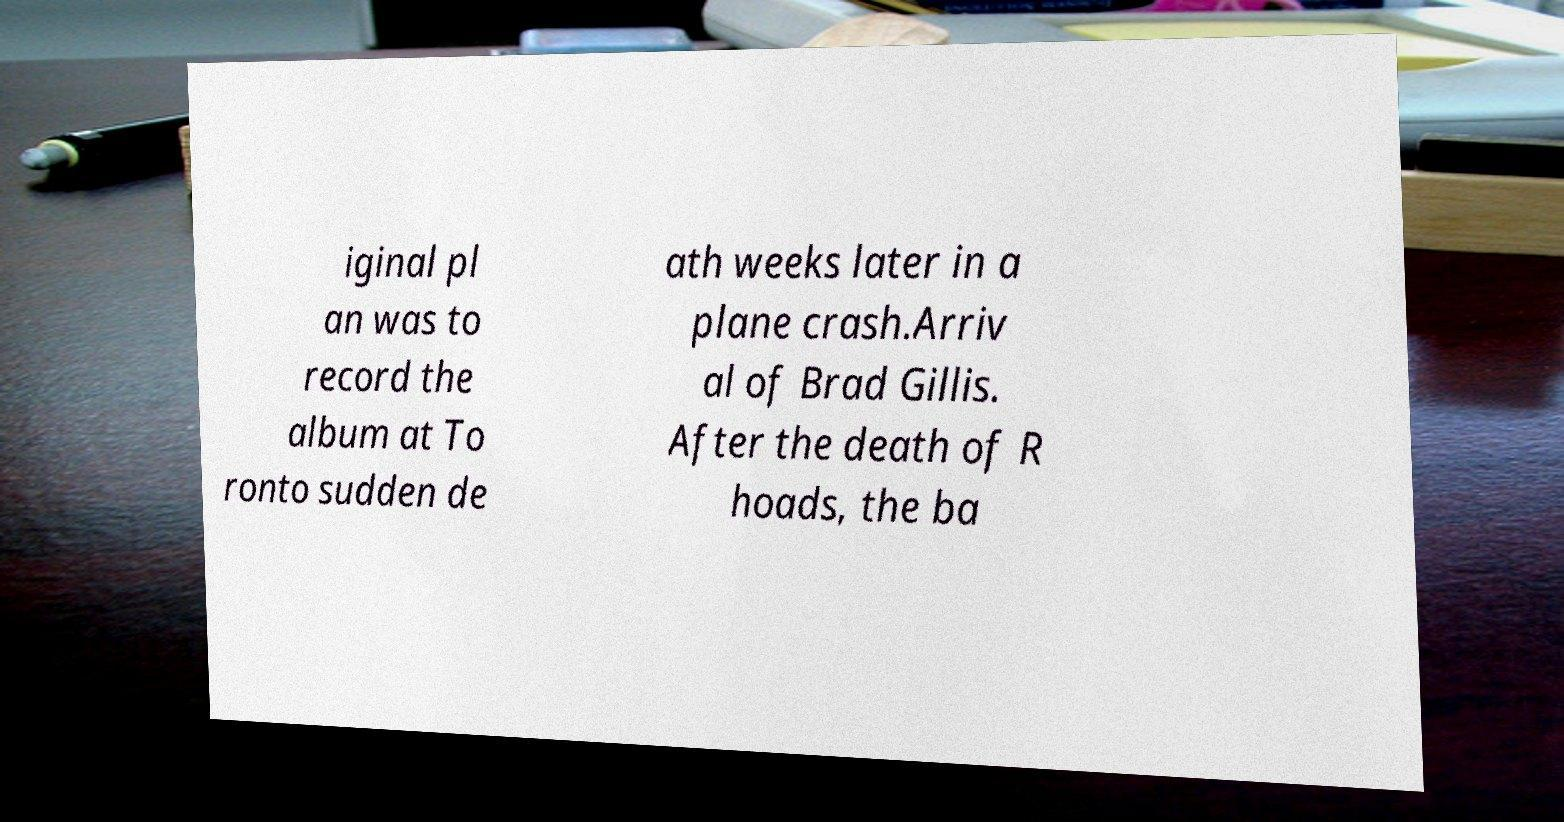Please read and relay the text visible in this image. What does it say? iginal pl an was to record the album at To ronto sudden de ath weeks later in a plane crash.Arriv al of Brad Gillis. After the death of R hoads, the ba 